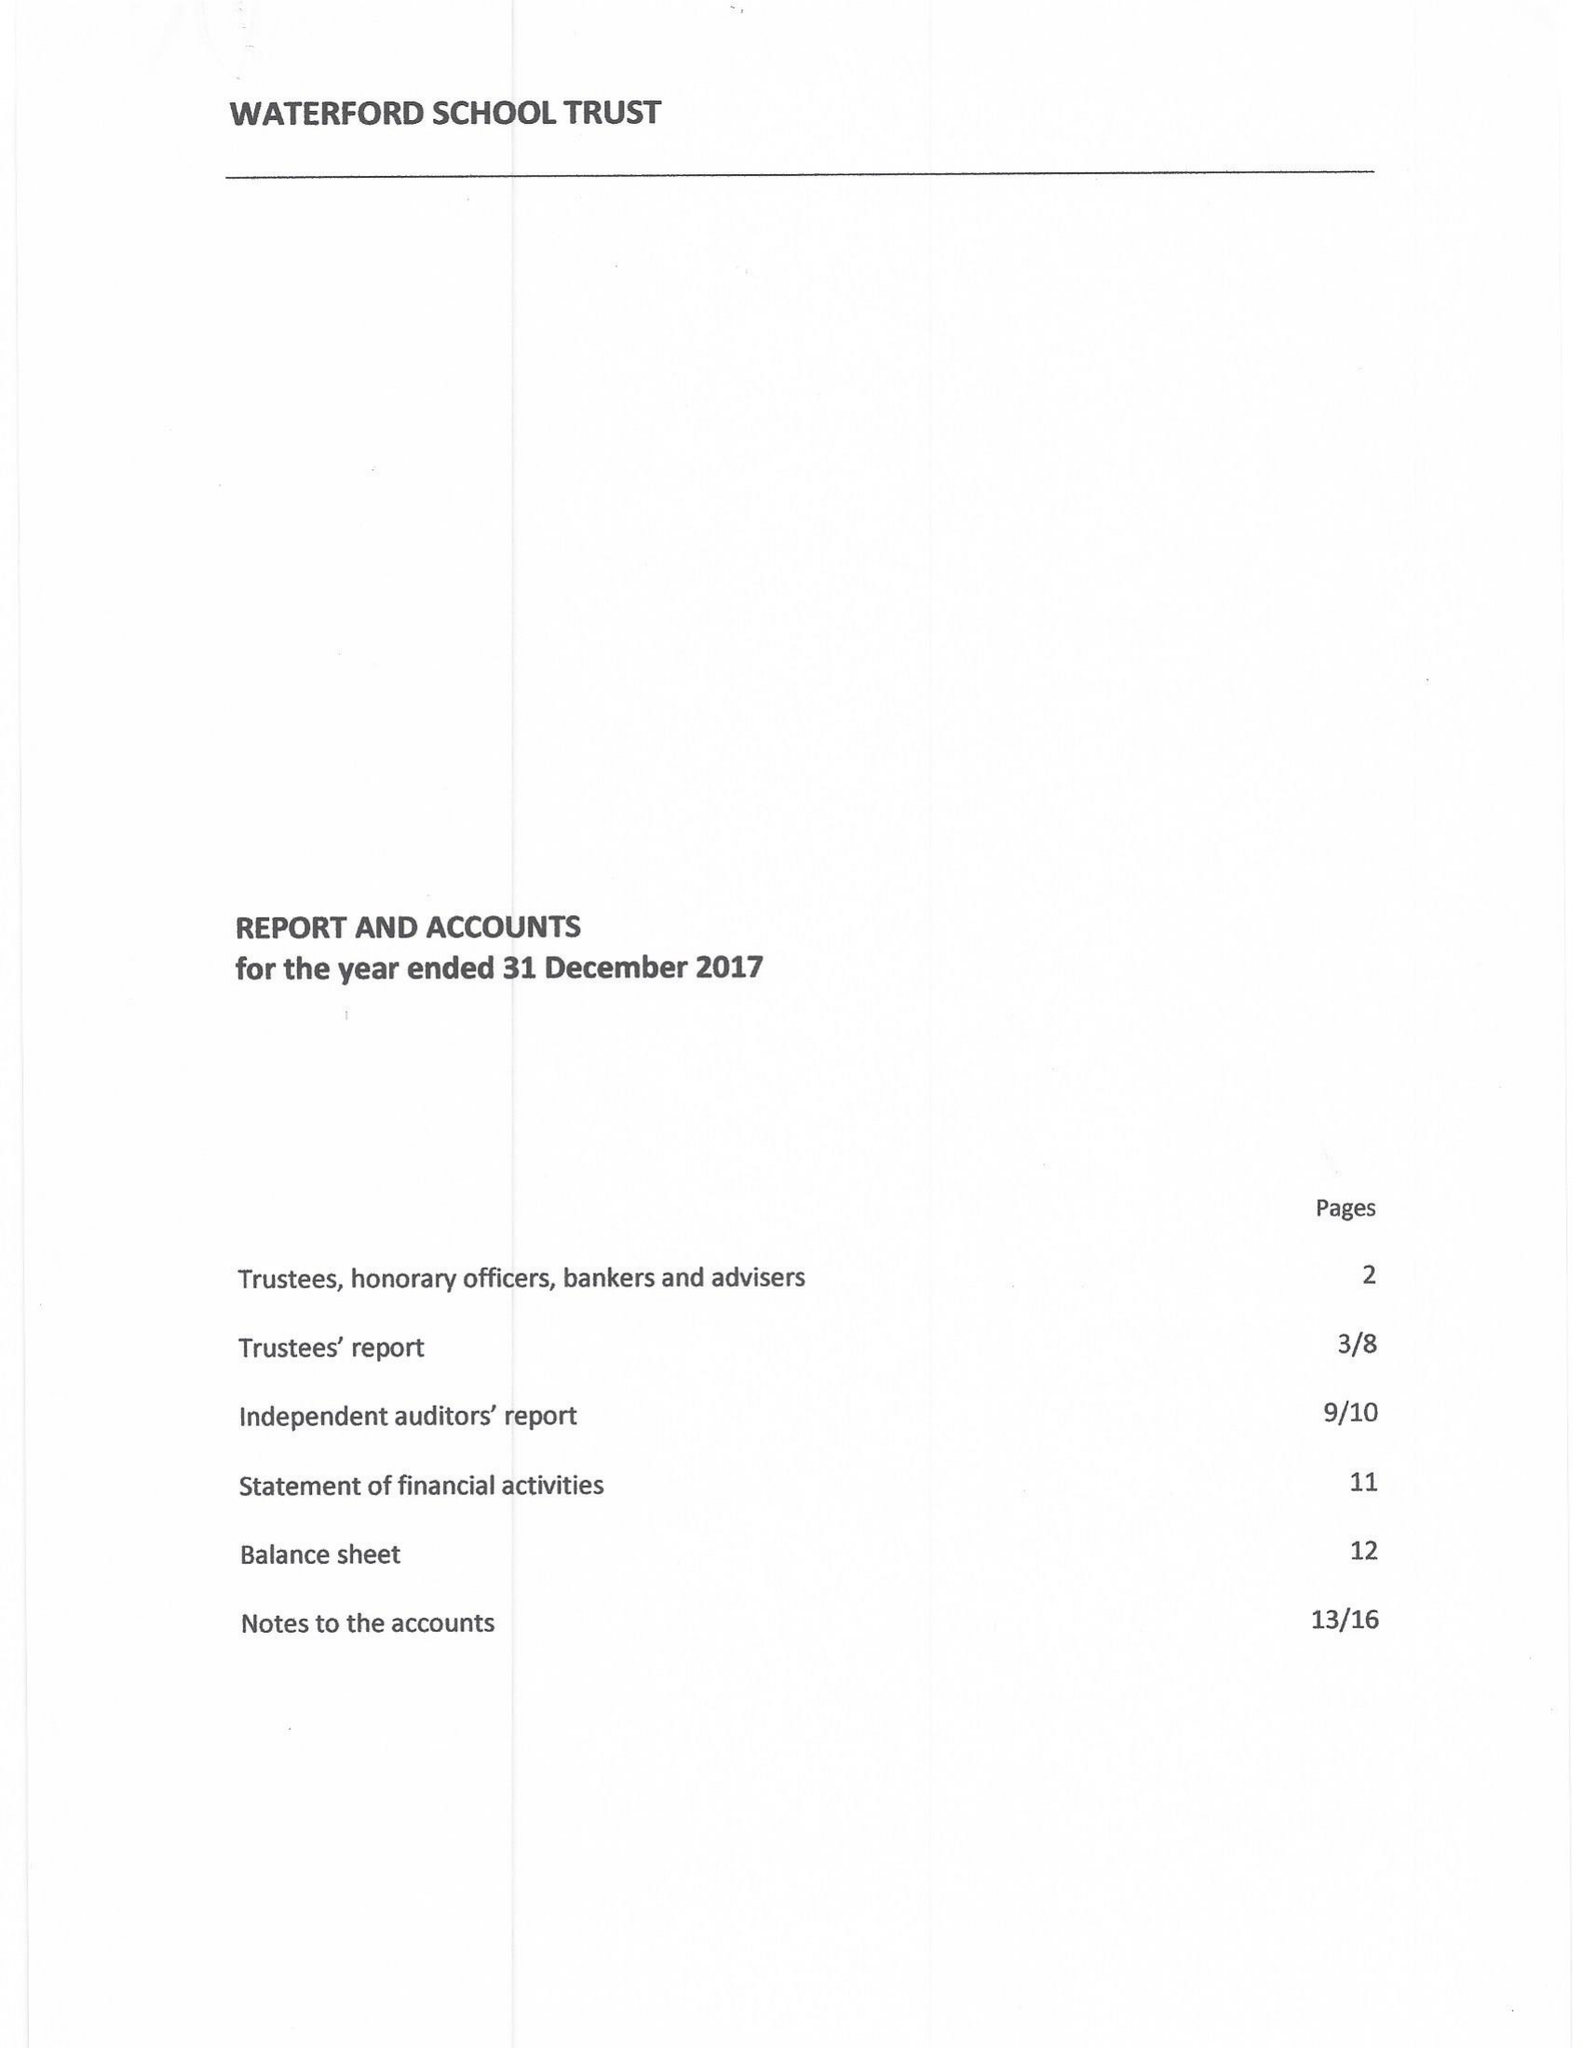What is the value for the charity_number?
Answer the question using a single word or phrase. 313908 